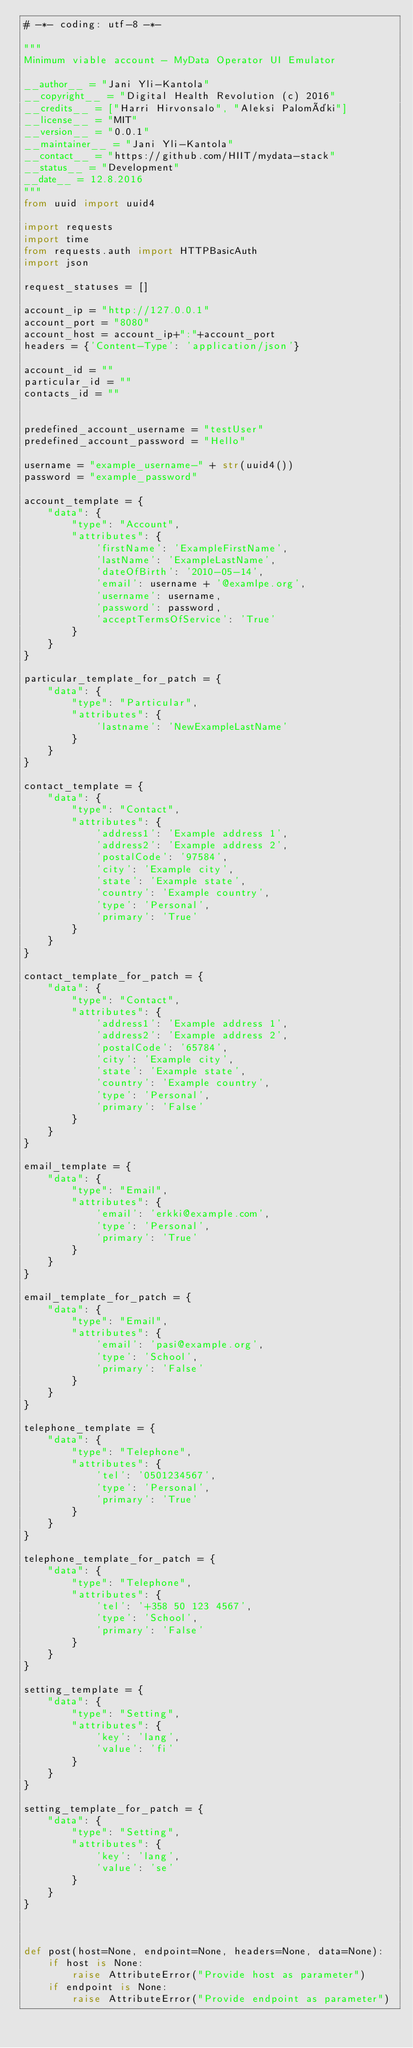Convert code to text. <code><loc_0><loc_0><loc_500><loc_500><_Python_># -*- coding: utf-8 -*-

"""
Minimum viable account - MyData Operator UI Emulator

__author__ = "Jani Yli-Kantola"
__copyright__ = "Digital Health Revolution (c) 2016"
__credits__ = ["Harri Hirvonsalo", "Aleksi Palomäki"]
__license__ = "MIT"
__version__ = "0.0.1"
__maintainer__ = "Jani Yli-Kantola"
__contact__ = "https://github.com/HIIT/mydata-stack"
__status__ = "Development"
__date__ = 12.8.2016
"""
from uuid import uuid4

import requests
import time
from requests.auth import HTTPBasicAuth
import json

request_statuses = []

account_ip = "http://127.0.0.1"
account_port = "8080"
account_host = account_ip+":"+account_port
headers = {'Content-Type': 'application/json'}

account_id = ""
particular_id = ""
contacts_id = ""


predefined_account_username = "testUser"
predefined_account_password = "Hello"

username = "example_username-" + str(uuid4())
password = "example_password"

account_template = {
    "data": {
        "type": "Account",
        "attributes": {
            'firstName': 'ExampleFirstName',
            'lastName': 'ExampleLastName',
            'dateOfBirth': '2010-05-14',
            'email': username + '@examlpe.org',
            'username': username,
            'password': password,
            'acceptTermsOfService': 'True'
        }
    }
}

particular_template_for_patch = {
    "data": {
        "type": "Particular",
        "attributes": {
            'lastname': 'NewExampleLastName'
        }
    }
}

contact_template = {
    "data": {
        "type": "Contact",
        "attributes": {
            'address1': 'Example address 1',
            'address2': 'Example address 2',
            'postalCode': '97584',
            'city': 'Example city',
            'state': 'Example state',
            'country': 'Example country',
            'type': 'Personal',
            'primary': 'True'
        }
    }
}

contact_template_for_patch = {
    "data": {
        "type": "Contact",
        "attributes": {
            'address1': 'Example address 1',
            'address2': 'Example address 2',
            'postalCode': '65784',
            'city': 'Example city',
            'state': 'Example state',
            'country': 'Example country',
            'type': 'Personal',
            'primary': 'False'
        }
    }
}

email_template = {
    "data": {
        "type": "Email",
        "attributes": {
            'email': 'erkki@example.com',
            'type': 'Personal',
            'primary': 'True'
        }
    }
}

email_template_for_patch = {
    "data": {
        "type": "Email",
        "attributes": {
            'email': 'pasi@example.org',
            'type': 'School',
            'primary': 'False'
        }
    }
}

telephone_template = {
    "data": {
        "type": "Telephone",
        "attributes": {
            'tel': '0501234567',
            'type': 'Personal',
            'primary': 'True'
        }
    }
}

telephone_template_for_patch = {
    "data": {
        "type": "Telephone",
        "attributes": {
            'tel': '+358 50 123 4567',
            'type': 'School',
            'primary': 'False'
        }
    }
}

setting_template = {
    "data": {
        "type": "Setting",
        "attributes": {
            'key': 'lang',
            'value': 'fi'
        }
    }
}

setting_template_for_patch = {
    "data": {
        "type": "Setting",
        "attributes": {
            'key': 'lang',
            'value': 'se'
        }
    }
}



def post(host=None, endpoint=None, headers=None, data=None):
    if host is None:
        raise AttributeError("Provide host as parameter")
    if endpoint is None:
        raise AttributeError("Provide endpoint as parameter")</code> 